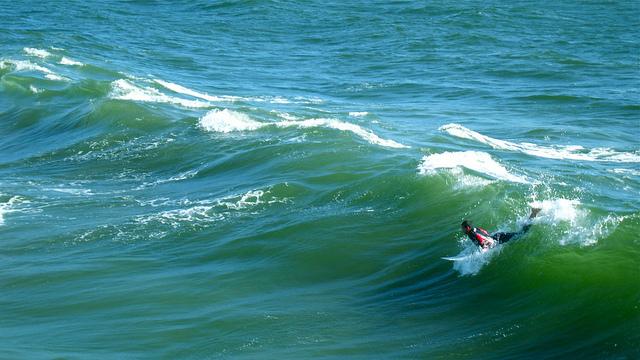How many surfers are there?
Quick response, please. 1. What is the surfer laying on?
Answer briefly. Surfboard. Why are the waves so small?
Answer briefly. No wind. 